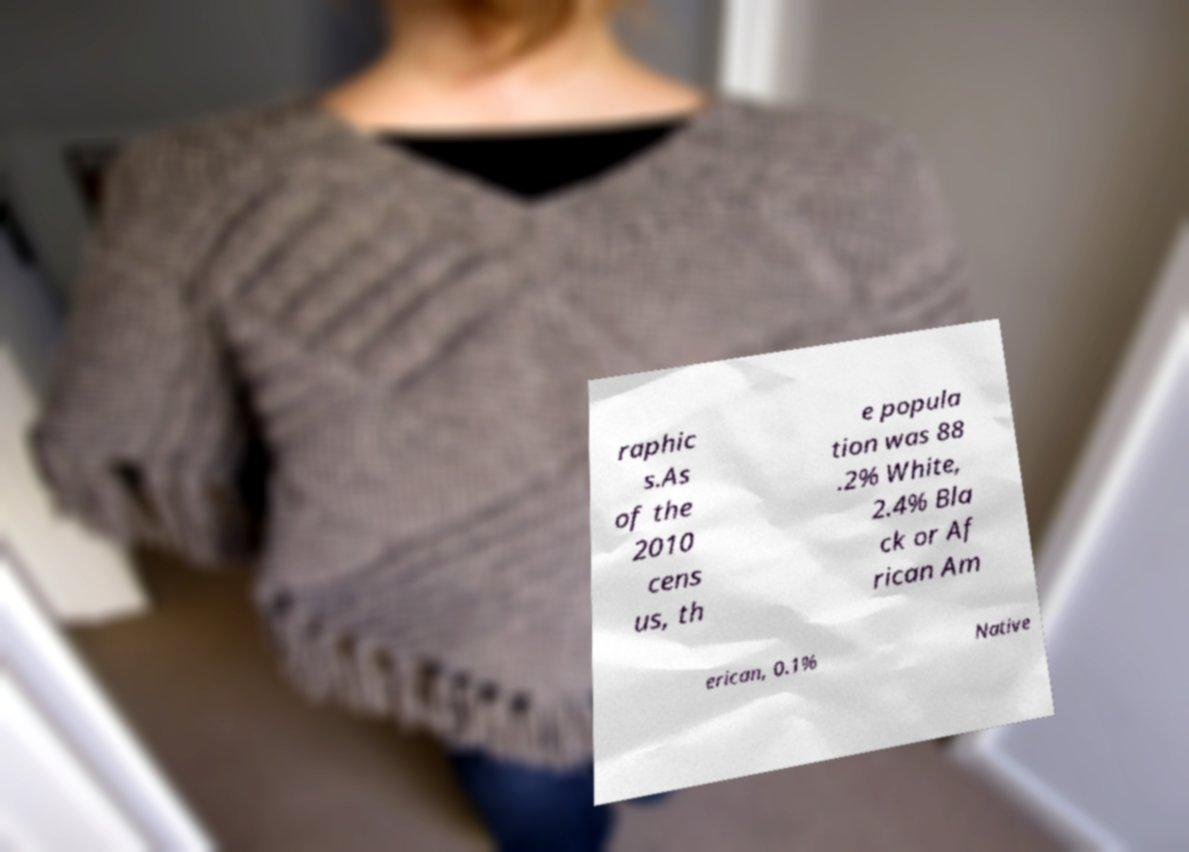Please read and relay the text visible in this image. What does it say? raphic s.As of the 2010 cens us, th e popula tion was 88 .2% White, 2.4% Bla ck or Af rican Am erican, 0.1% Native 